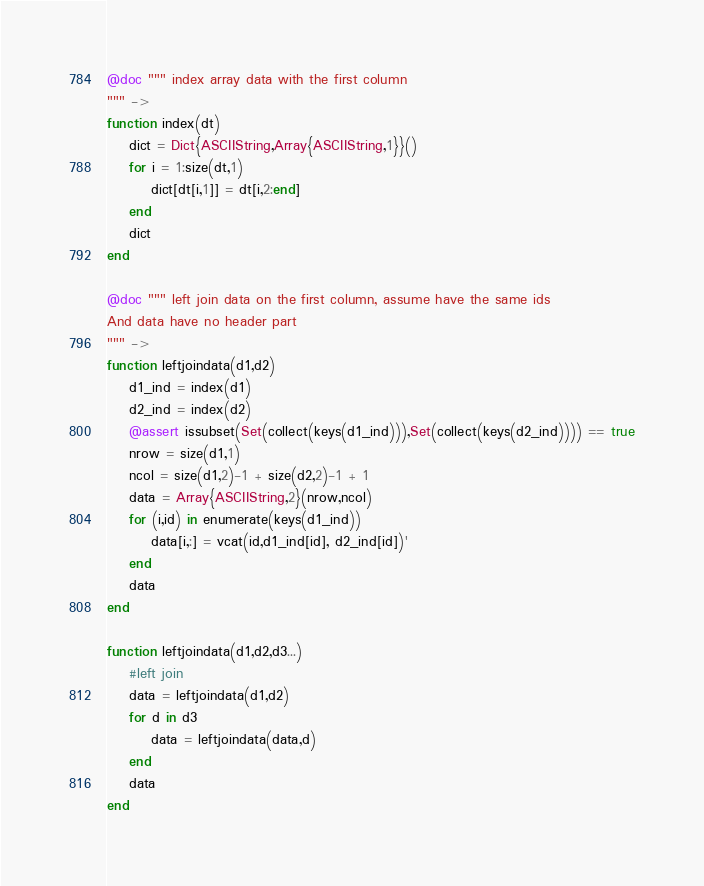Convert code to text. <code><loc_0><loc_0><loc_500><loc_500><_Julia_>@doc """ index array data with the first column
""" ->
function index(dt)
    dict = Dict{ASCIIString,Array{ASCIIString,1}}()
    for i = 1:size(dt,1)
        dict[dt[i,1]] = dt[i,2:end]
    end
    dict
end

@doc """ left join data on the first column, assume have the same ids
And data have no header part
""" ->
function leftjoindata(d1,d2)
    d1_ind = index(d1)
    d2_ind = index(d2)
    @assert issubset(Set(collect(keys(d1_ind))),Set(collect(keys(d2_ind)))) == true
    nrow = size(d1,1)
    ncol = size(d1,2)-1 + size(d2,2)-1 + 1
    data = Array{ASCIIString,2}(nrow,ncol)
    for (i,id) in enumerate(keys(d1_ind))
        data[i,:] = vcat(id,d1_ind[id], d2_ind[id])'
    end
    data
end

function leftjoindata(d1,d2,d3...)
    #left join
    data = leftjoindata(d1,d2)
    for d in d3
        data = leftjoindata(data,d)
    end
    data
end
</code> 